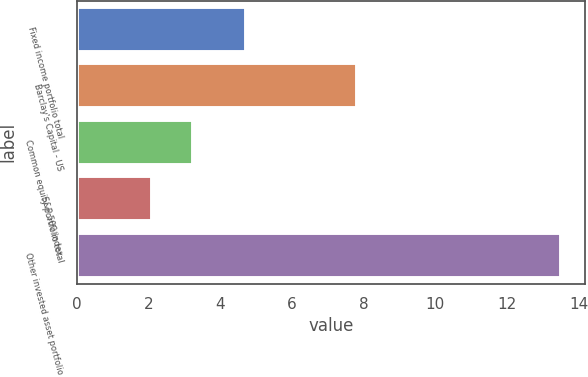Convert chart to OTSL. <chart><loc_0><loc_0><loc_500><loc_500><bar_chart><fcel>Fixed income portfolio total<fcel>Barclay's Capital - US<fcel>Common equity portfolio total<fcel>S&P 500 index<fcel>Other invested asset portfolio<nl><fcel>4.7<fcel>7.8<fcel>3.24<fcel>2.1<fcel>13.5<nl></chart> 